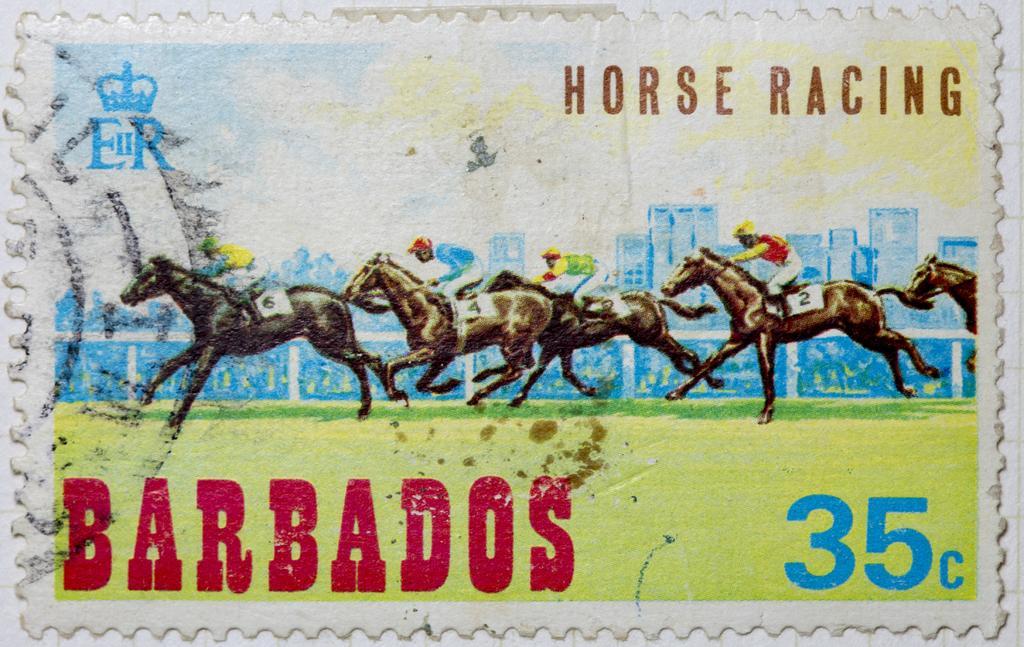Could you give a brief overview of what you see in this image? In this picture I can see a painting of people sitting on the horses. Here I can see some names written on it. 